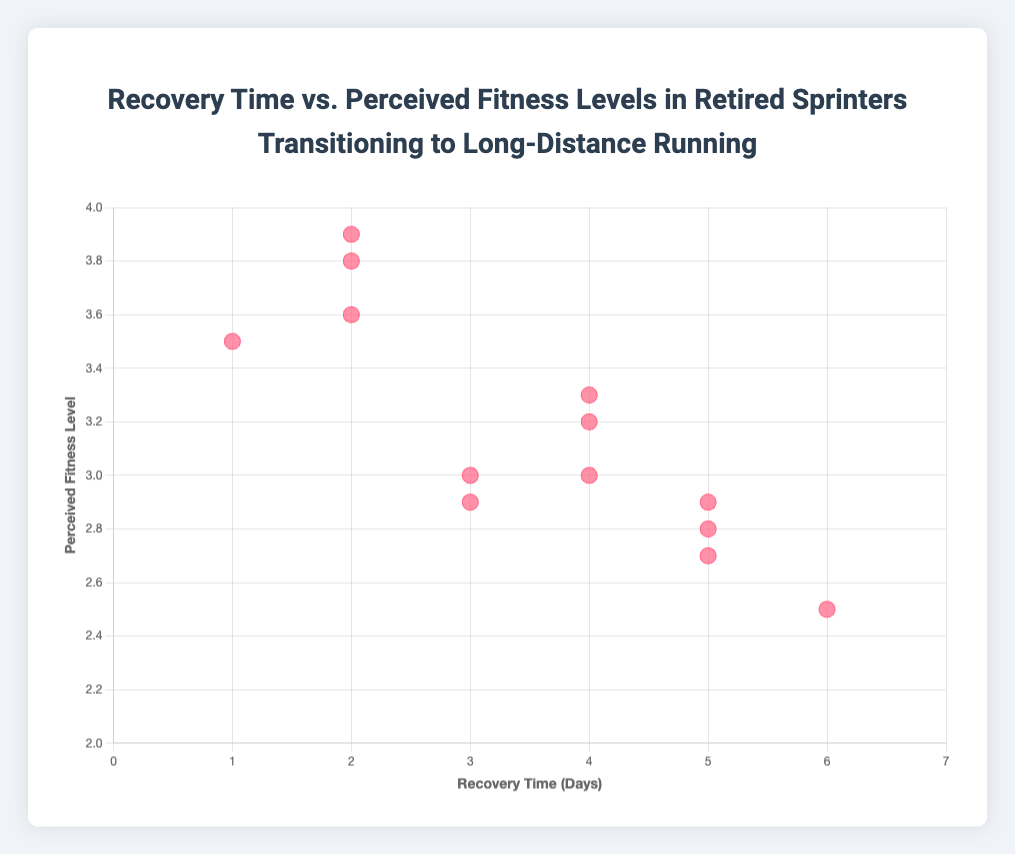What is the title of the scatter plot? The title of the scatter plot is usually displayed at the top of the figure, indicating the subject of the data being visualized.
Answer: Recovery Time vs. Perceived Fitness Levels in Retired Sprinters Transitioning to Long-Distance Running What is the value of the recovery time for the data point with the highest perceived fitness level? The highest perceived fitness level in the data is 3.9, which corresponds to the recovery time value of 2 days as shown in the plotted data points.
Answer: 2 days How many data points have a recovery time of 4 days? By counting the data points on the scatter plot, you will find that there are three points situated at the recovery time of 4 days, associated with the perceived fitness levels of 3.2, 3.0, and 3.3 respectively.
Answer: 3 data points Who has the longest recovery time in the data set and what is their perceived fitness level? The longest recovery time is 6 days, and according to the tooltip on the scatter plot, Michael Johnson corresponds to this recovery time with a perceived fitness level of 2.5.
Answer: Michael Johnson, 2.5 Which runner has a recovery time of 1 day and what is their perceived fitness level? By referring to the data points labeled with each runner's name, the runner with a recovery time of 1 day is Usain Bolt, and his perceived fitness level is marked as 3.5 on the scatter plot.
Answer: Usain Bolt, 3.5 Compare the perceived fitness levels of runners with 3 days of recovery time. Who has the highest and lowest perceived fitness levels? Observing the data points, there are three runners with 3 days of recovery time. Tyson Gay has a perceived fitness level of 2.9, Donovan Bailey has 3.0, and these levels can be directly compared to determine the one with the highest and the lowest.
Answer: Donovan Bailey (highest: 3.0), Tyson Gay (lowest: 2.9) What is the average perceived fitness level for runners with a recovery time of 2 days? The recovery times at 2 days correspond to the perceived fitness levels of 3.8, 3.6, and 3.9. Adding these together yields 3.8 + 3.6 + 3.9 = 11.3, and dividing them by the number of runners, 11.3/3, gives the average.
Answer: 3.77 What trend can you observe between recovery time and perceived fitness level in this scatter plot? By evaluating the scatter plot, you may notice a general trend where runners with shorter recovery times tend to have higher perceived fitness levels. This indicates an inverse relationship where higher fitness levels are associated with shorter recovery times.
Answer: Higher fitness levels correlate with shorter recovery times Is there any runner with a perceived fitness level of exactly 3.3 and what is their recovery time? Scanning the scatter plot, you find that there is one runner with a perceived fitness level of 3.3, which corresponds to a recovery time of 4 days. According to the tooltip, this runner is Evelyn Ashford.
Answer: Evelyn Ashford, 4 days 